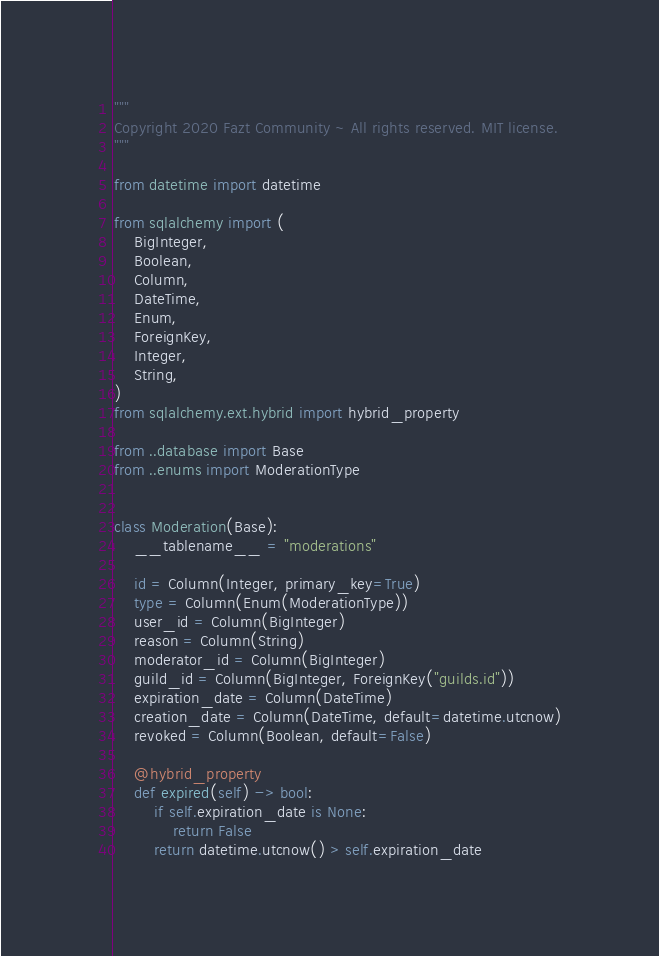<code> <loc_0><loc_0><loc_500><loc_500><_Python_>"""
Copyright 2020 Fazt Community ~ All rights reserved. MIT license.
"""

from datetime import datetime

from sqlalchemy import (
    BigInteger,
    Boolean,
    Column,
    DateTime,
    Enum,
    ForeignKey,
    Integer,
    String,
)
from sqlalchemy.ext.hybrid import hybrid_property

from ..database import Base
from ..enums import ModerationType


class Moderation(Base):
    __tablename__ = "moderations"

    id = Column(Integer, primary_key=True)
    type = Column(Enum(ModerationType))
    user_id = Column(BigInteger)
    reason = Column(String)
    moderator_id = Column(BigInteger)
    guild_id = Column(BigInteger, ForeignKey("guilds.id"))
    expiration_date = Column(DateTime)
    creation_date = Column(DateTime, default=datetime.utcnow)
    revoked = Column(Boolean, default=False)

    @hybrid_property
    def expired(self) -> bool:
        if self.expiration_date is None:
            return False
        return datetime.utcnow() > self.expiration_date
</code> 